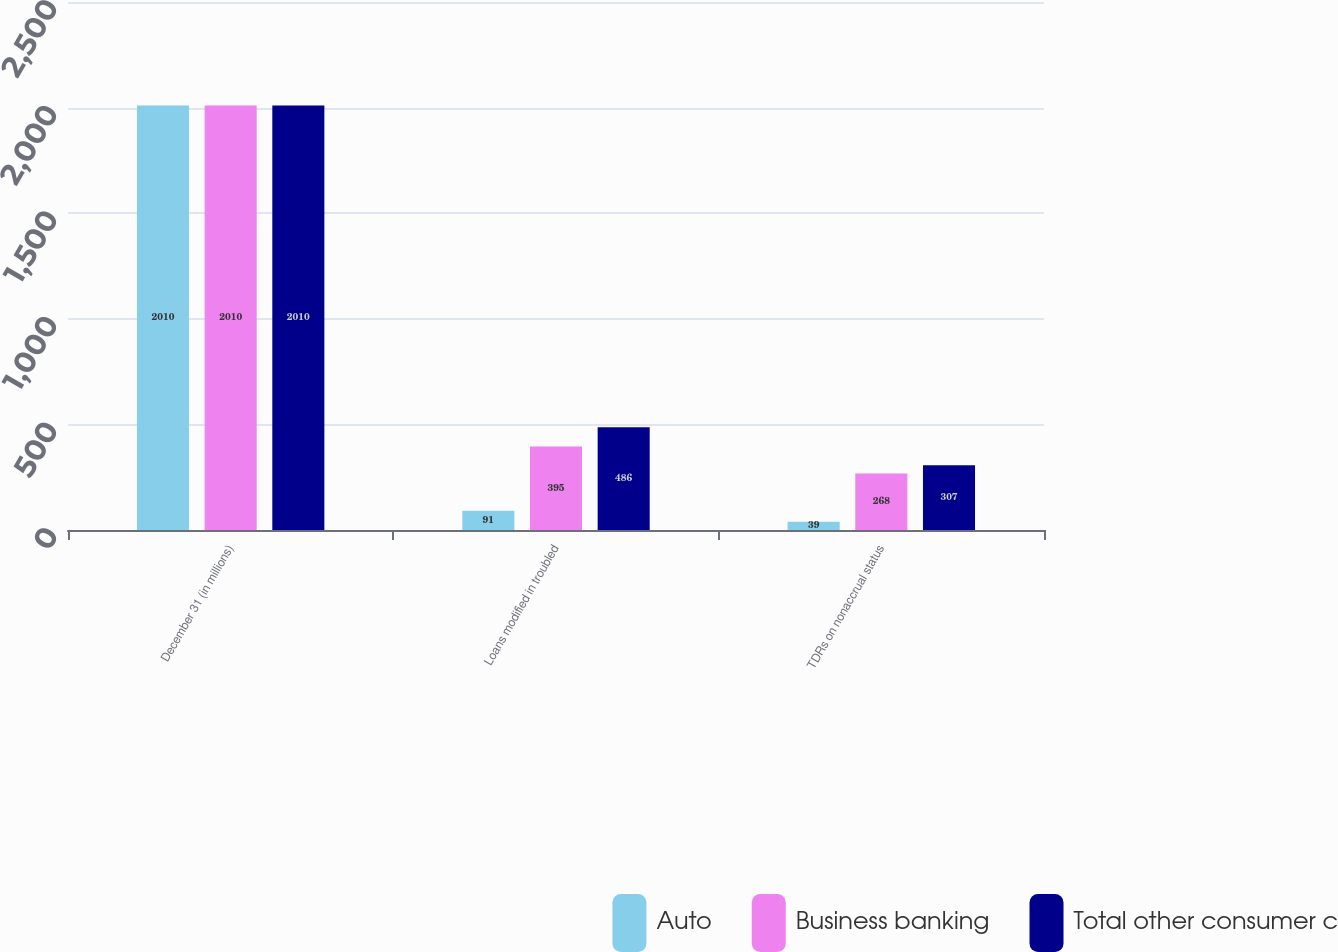<chart> <loc_0><loc_0><loc_500><loc_500><stacked_bar_chart><ecel><fcel>December 31 (in millions)<fcel>Loans modified in troubled<fcel>TDRs on nonaccrual status<nl><fcel>Auto<fcel>2010<fcel>91<fcel>39<nl><fcel>Business banking<fcel>2010<fcel>395<fcel>268<nl><fcel>Total other consumer c<fcel>2010<fcel>486<fcel>307<nl></chart> 